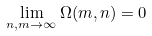<formula> <loc_0><loc_0><loc_500><loc_500>\lim _ { n , m \rightarrow \infty } \Omega ( m , n ) = 0</formula> 